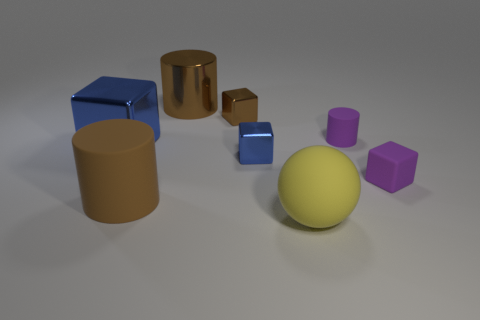Add 2 big blue shiny objects. How many objects exist? 10 Subtract all spheres. How many objects are left? 7 Subtract all big brown rubber things. Subtract all large metallic cubes. How many objects are left? 6 Add 1 big yellow rubber balls. How many big yellow rubber balls are left? 2 Add 1 yellow cubes. How many yellow cubes exist? 1 Subtract 0 green cubes. How many objects are left? 8 